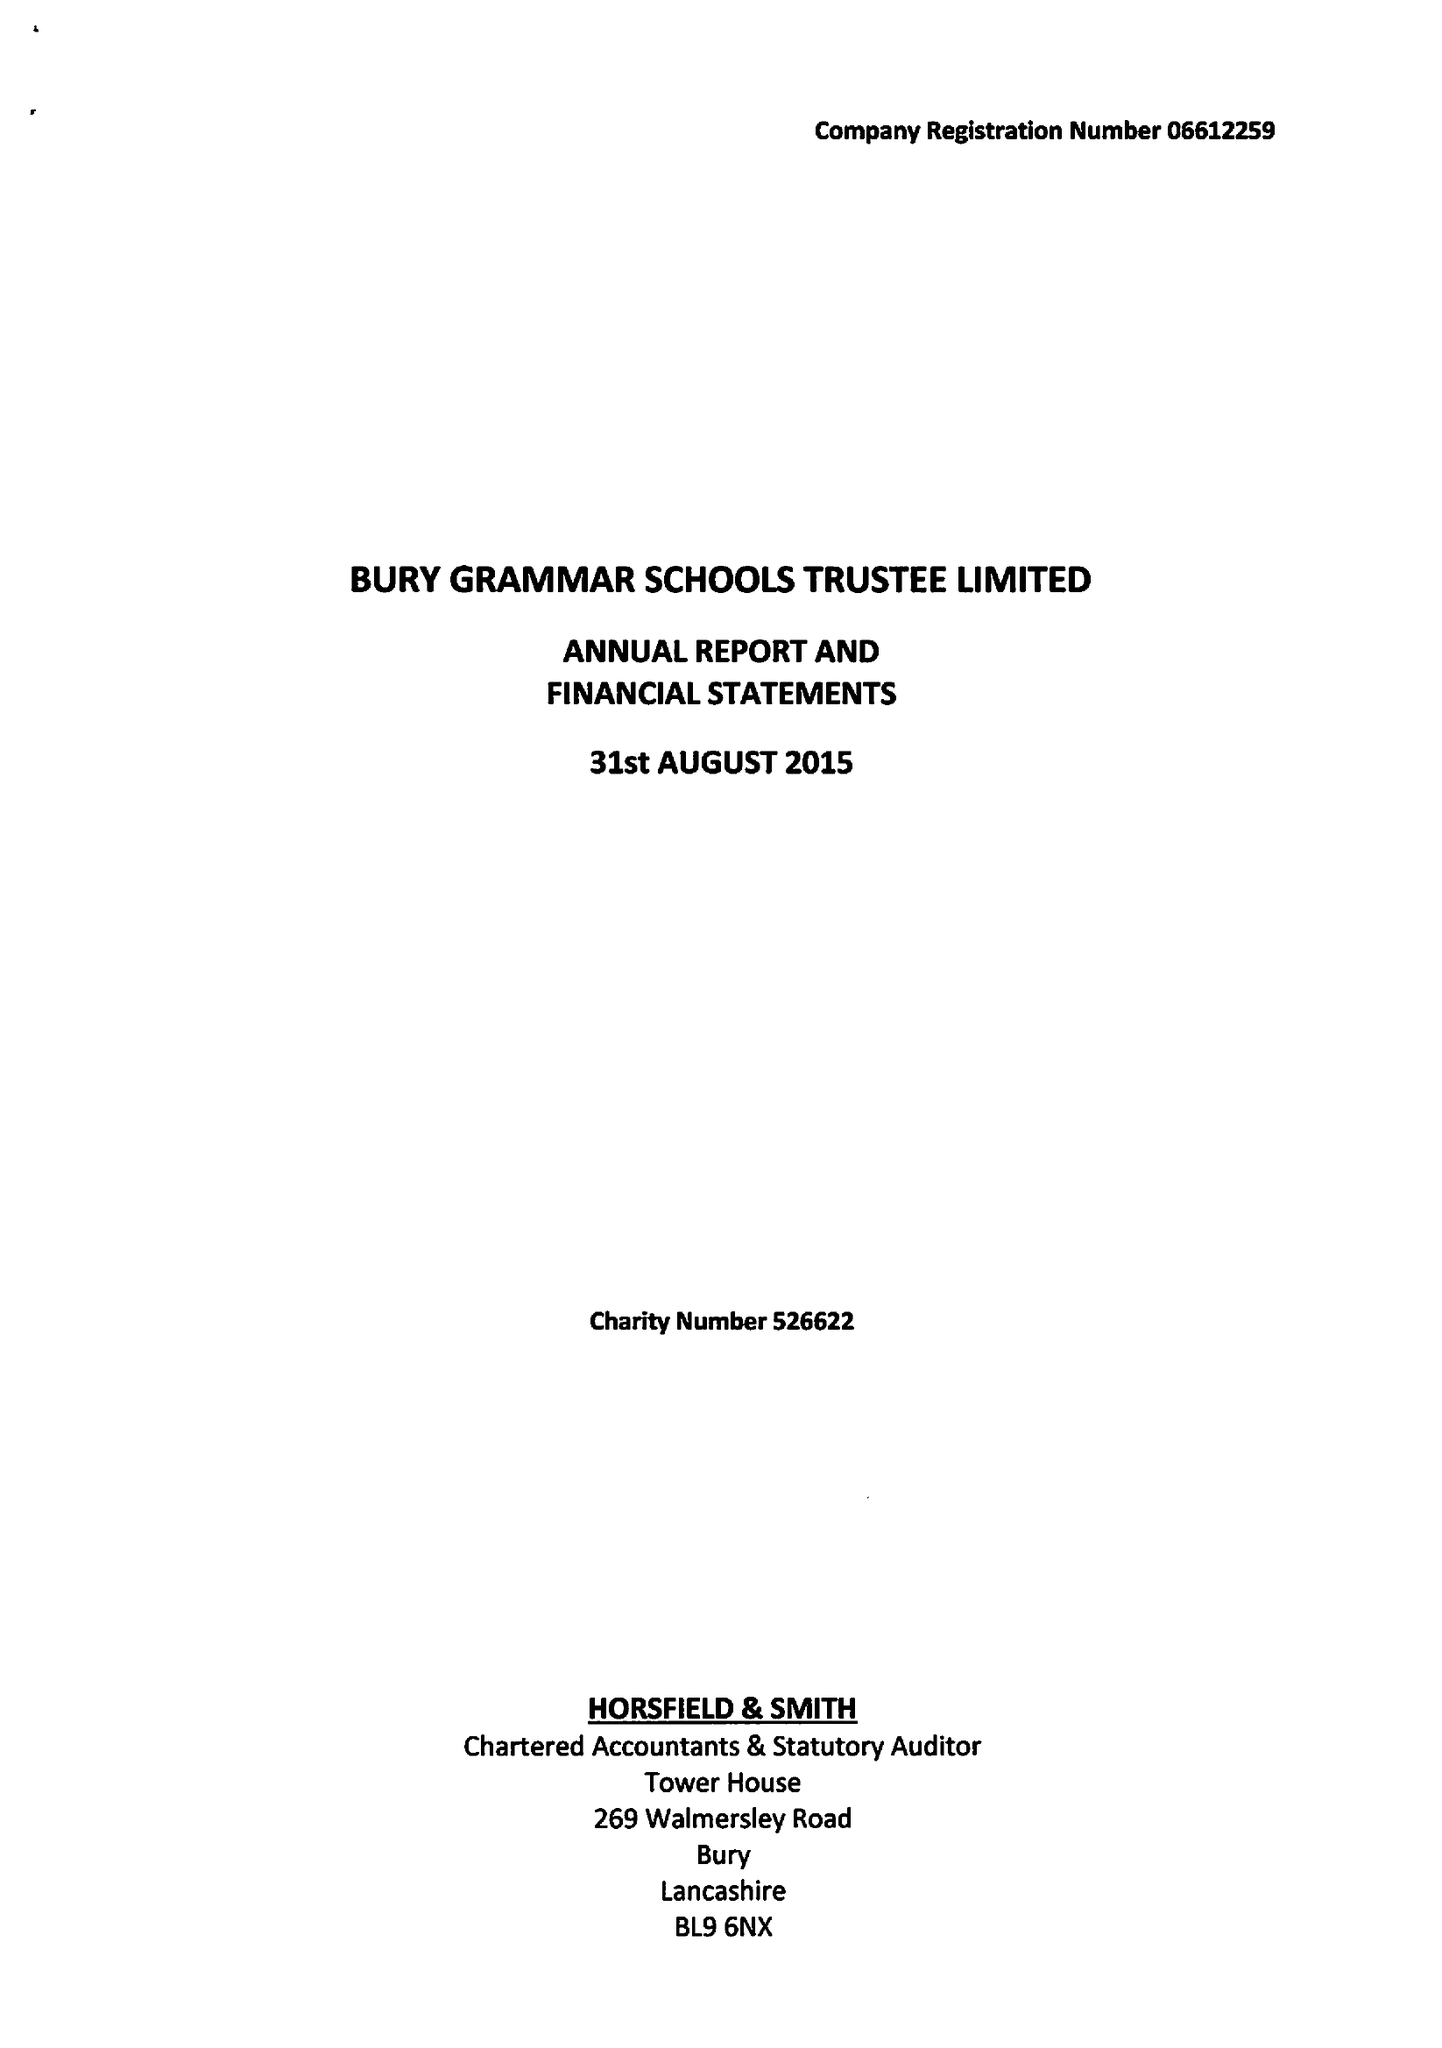What is the value for the address__street_line?
Answer the question using a single word or phrase. BRIDGE ROAD 